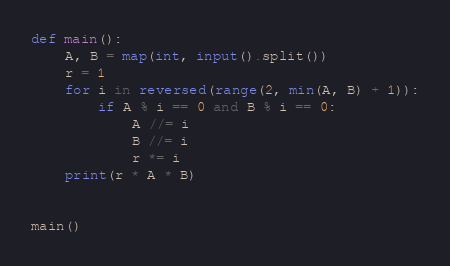<code> <loc_0><loc_0><loc_500><loc_500><_Python_>def main():
    A, B = map(int, input().split())
    r = 1
    for i in reversed(range(2, min(A, B) + 1)):
        if A % i == 0 and B % i == 0:
            A //= i
            B //= i
            r *= i
    print(r * A * B)


main()
</code> 